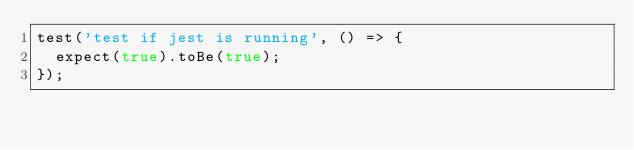Convert code to text. <code><loc_0><loc_0><loc_500><loc_500><_JavaScript_>test('test if jest is running', () => {
  expect(true).toBe(true);
});
</code> 